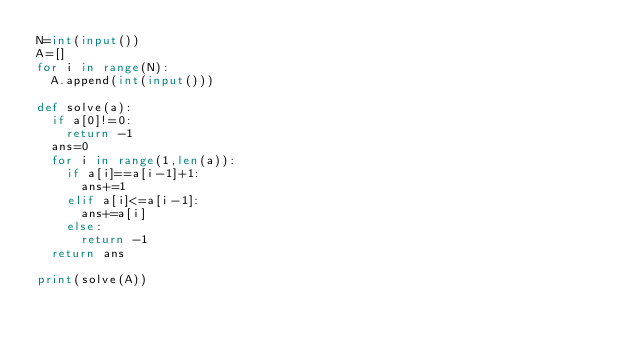<code> <loc_0><loc_0><loc_500><loc_500><_Python_>N=int(input())
A=[]
for i in range(N):
  A.append(int(input()))

def solve(a):
  if a[0]!=0:
    return -1
  ans=0
  for i in range(1,len(a)):
    if a[i]==a[i-1]+1:
      ans+=1
    elif a[i]<=a[i-1]:
      ans+=a[i]
    else:
      return -1
  return ans

print(solve(A))</code> 